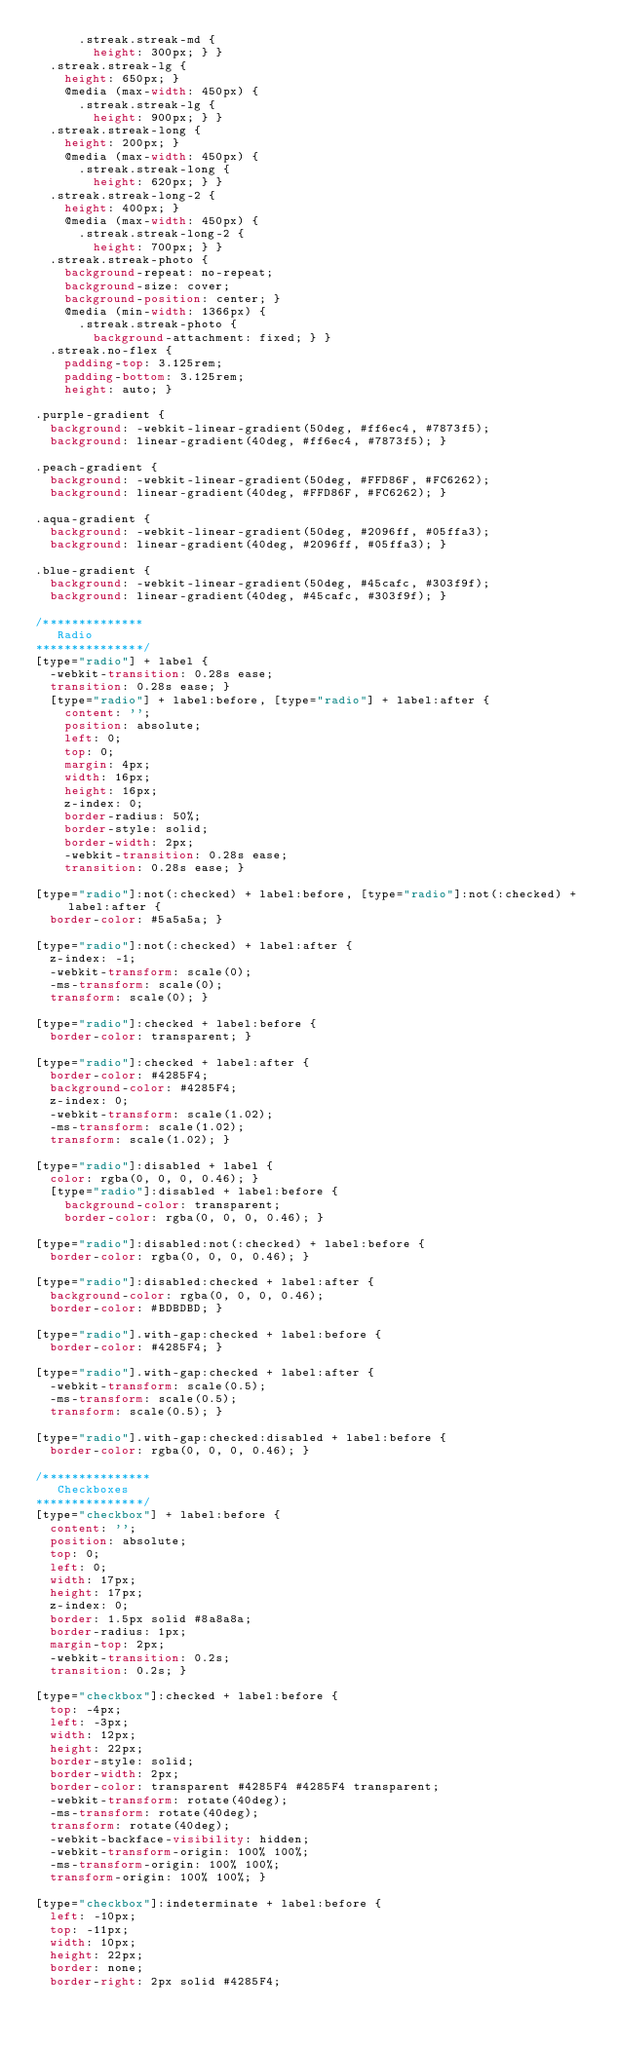Convert code to text. <code><loc_0><loc_0><loc_500><loc_500><_CSS_>      .streak.streak-md {
        height: 300px; } }
  .streak.streak-lg {
    height: 650px; }
    @media (max-width: 450px) {
      .streak.streak-lg {
        height: 900px; } }
  .streak.streak-long {
    height: 200px; }
    @media (max-width: 450px) {
      .streak.streak-long {
        height: 620px; } }
  .streak.streak-long-2 {
    height: 400px; }
    @media (max-width: 450px) {
      .streak.streak-long-2 {
        height: 700px; } }
  .streak.streak-photo {
    background-repeat: no-repeat;
    background-size: cover;
    background-position: center; }
    @media (min-width: 1366px) {
      .streak.streak-photo {
        background-attachment: fixed; } }
  .streak.no-flex {
    padding-top: 3.125rem;
    padding-bottom: 3.125rem;
    height: auto; }

.purple-gradient {
  background: -webkit-linear-gradient(50deg, #ff6ec4, #7873f5);
  background: linear-gradient(40deg, #ff6ec4, #7873f5); }

.peach-gradient {
  background: -webkit-linear-gradient(50deg, #FFD86F, #FC6262);
  background: linear-gradient(40deg, #FFD86F, #FC6262); }

.aqua-gradient {
  background: -webkit-linear-gradient(50deg, #2096ff, #05ffa3);
  background: linear-gradient(40deg, #2096ff, #05ffa3); }

.blue-gradient {
  background: -webkit-linear-gradient(50deg, #45cafc, #303f9f);
  background: linear-gradient(40deg, #45cafc, #303f9f); }

/**************
   Radio
***************/
[type="radio"] + label {
  -webkit-transition: 0.28s ease;
  transition: 0.28s ease; }
  [type="radio"] + label:before, [type="radio"] + label:after {
    content: '';
    position: absolute;
    left: 0;
    top: 0;
    margin: 4px;
    width: 16px;
    height: 16px;
    z-index: 0;
    border-radius: 50%;
    border-style: solid;
    border-width: 2px;
    -webkit-transition: 0.28s ease;
    transition: 0.28s ease; }

[type="radio"]:not(:checked) + label:before, [type="radio"]:not(:checked) + label:after {
  border-color: #5a5a5a; }

[type="radio"]:not(:checked) + label:after {
  z-index: -1;
  -webkit-transform: scale(0);
  -ms-transform: scale(0);
  transform: scale(0); }

[type="radio"]:checked + label:before {
  border-color: transparent; }

[type="radio"]:checked + label:after {
  border-color: #4285F4;
  background-color: #4285F4;
  z-index: 0;
  -webkit-transform: scale(1.02);
  -ms-transform: scale(1.02);
  transform: scale(1.02); }

[type="radio"]:disabled + label {
  color: rgba(0, 0, 0, 0.46); }
  [type="radio"]:disabled + label:before {
    background-color: transparent;
    border-color: rgba(0, 0, 0, 0.46); }

[type="radio"]:disabled:not(:checked) + label:before {
  border-color: rgba(0, 0, 0, 0.46); }

[type="radio"]:disabled:checked + label:after {
  background-color: rgba(0, 0, 0, 0.46);
  border-color: #BDBDBD; }

[type="radio"].with-gap:checked + label:before {
  border-color: #4285F4; }

[type="radio"].with-gap:checked + label:after {
  -webkit-transform: scale(0.5);
  -ms-transform: scale(0.5);
  transform: scale(0.5); }

[type="radio"].with-gap:checked:disabled + label:before {
  border-color: rgba(0, 0, 0, 0.46); }

/***************
   Checkboxes
***************/
[type="checkbox"] + label:before {
  content: '';
  position: absolute;
  top: 0;
  left: 0;
  width: 17px;
  height: 17px;
  z-index: 0;
  border: 1.5px solid #8a8a8a;
  border-radius: 1px;
  margin-top: 2px;
  -webkit-transition: 0.2s;
  transition: 0.2s; }

[type="checkbox"]:checked + label:before {
  top: -4px;
  left: -3px;
  width: 12px;
  height: 22px;
  border-style: solid;
  border-width: 2px;
  border-color: transparent #4285F4 #4285F4 transparent;
  -webkit-transform: rotate(40deg);
  -ms-transform: rotate(40deg);
  transform: rotate(40deg);
  -webkit-backface-visibility: hidden;
  -webkit-transform-origin: 100% 100%;
  -ms-transform-origin: 100% 100%;
  transform-origin: 100% 100%; }

[type="checkbox"]:indeterminate + label:before {
  left: -10px;
  top: -11px;
  width: 10px;
  height: 22px;
  border: none;
  border-right: 2px solid #4285F4;</code> 